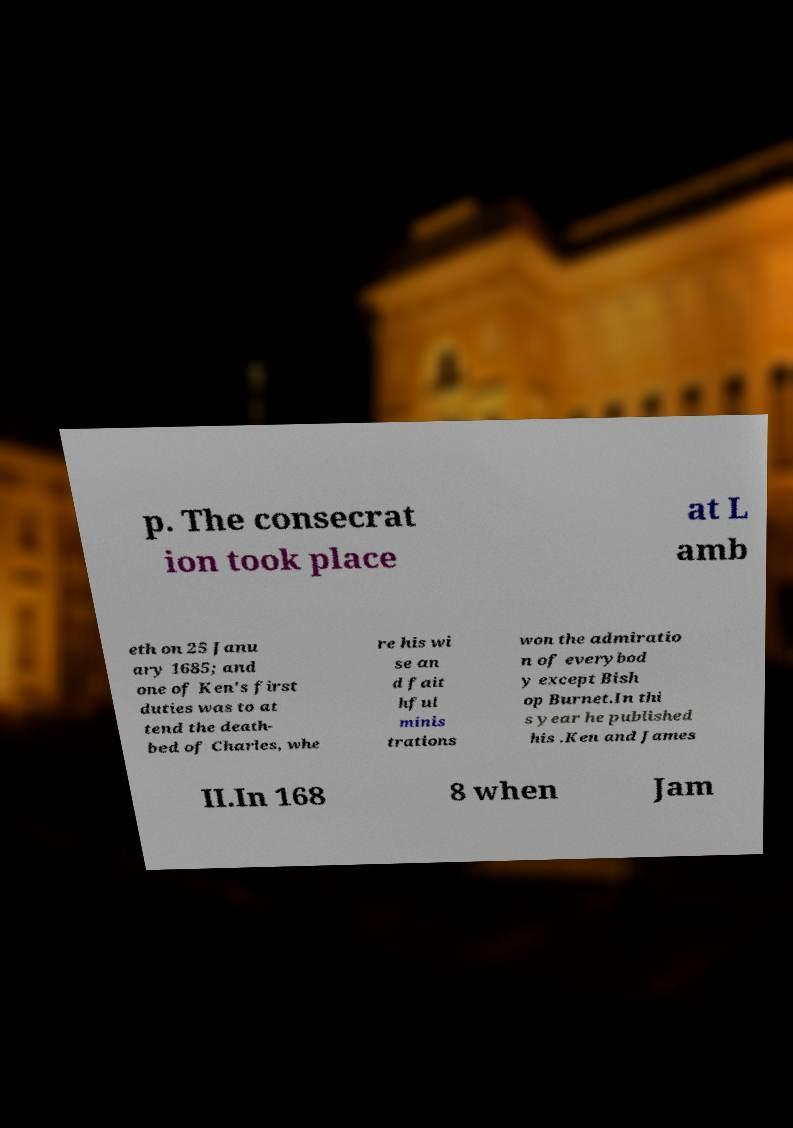Can you accurately transcribe the text from the provided image for me? p. The consecrat ion took place at L amb eth on 25 Janu ary 1685; and one of Ken's first duties was to at tend the death- bed of Charles, whe re his wi se an d fait hful minis trations won the admiratio n of everybod y except Bish op Burnet.In thi s year he published his .Ken and James II.In 168 8 when Jam 